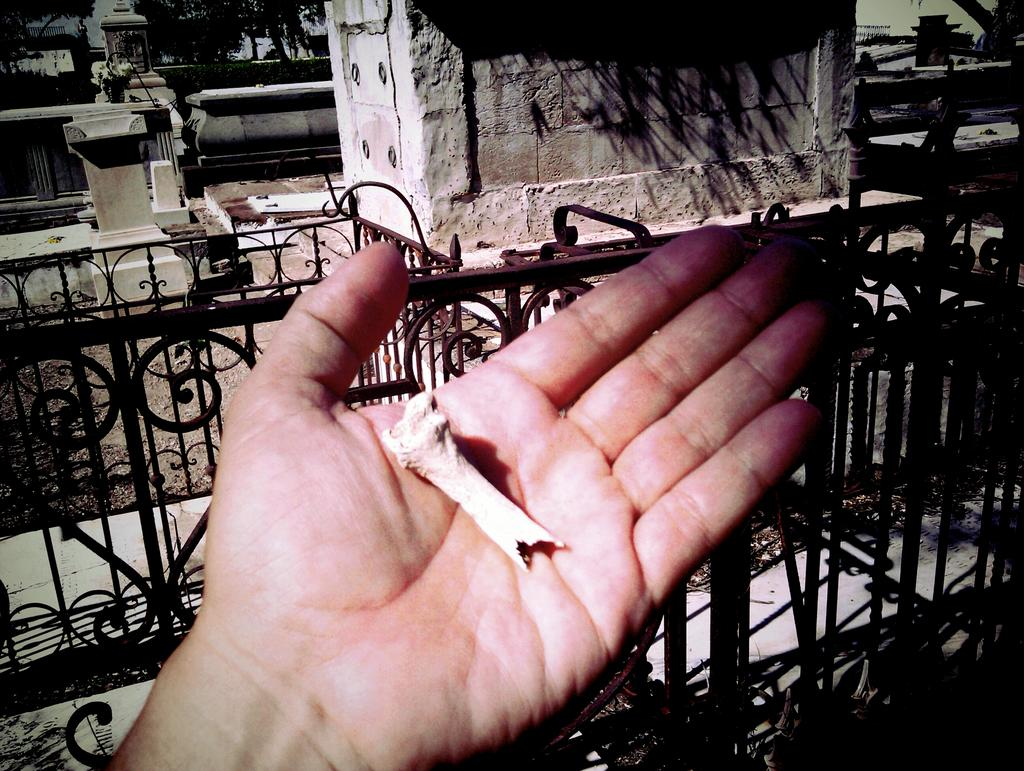What part of a person's body is visible in the image? There is a person's hand in the image. What can be seen in the distance behind the hand? There are buildings and trees in the background of the image. What time of day is it in the image, based on the hour? The provided facts do not mention the time of day or any hour, so it cannot be determined from the image. 